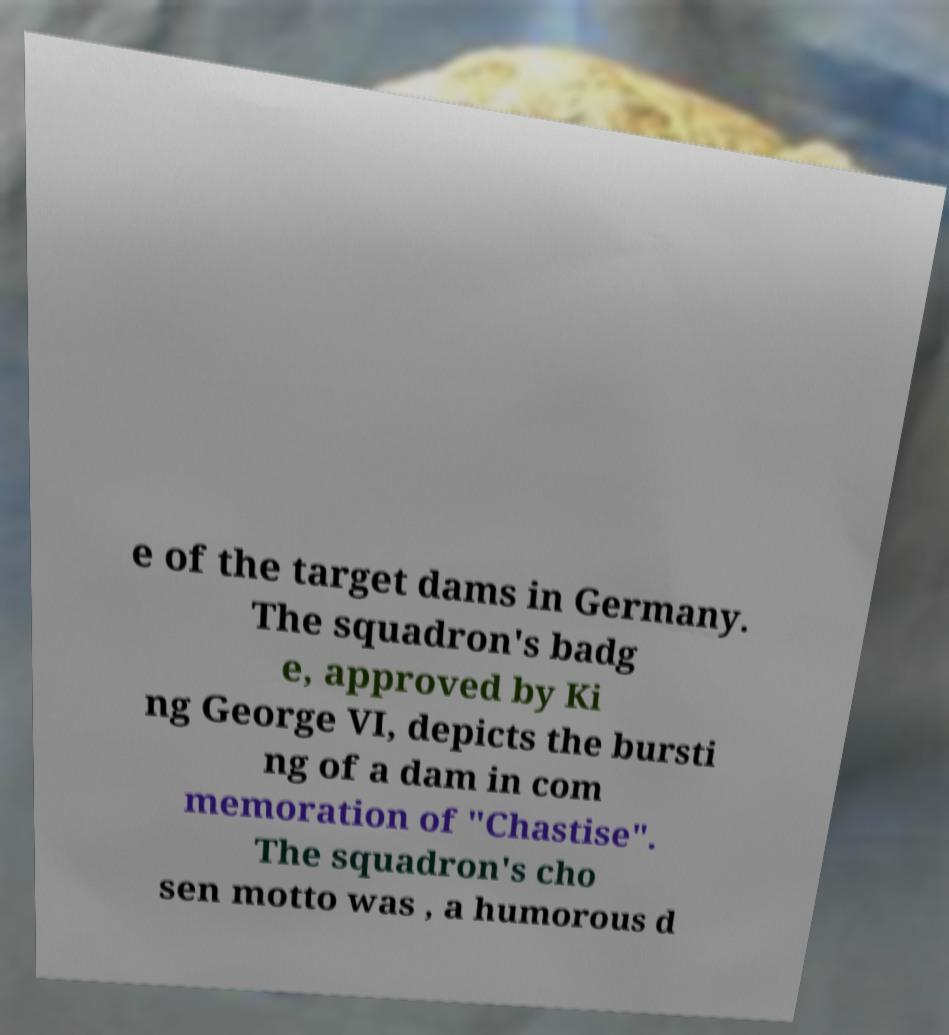Could you assist in decoding the text presented in this image and type it out clearly? e of the target dams in Germany. The squadron's badg e, approved by Ki ng George VI, depicts the bursti ng of a dam in com memoration of "Chastise". The squadron's cho sen motto was , a humorous d 